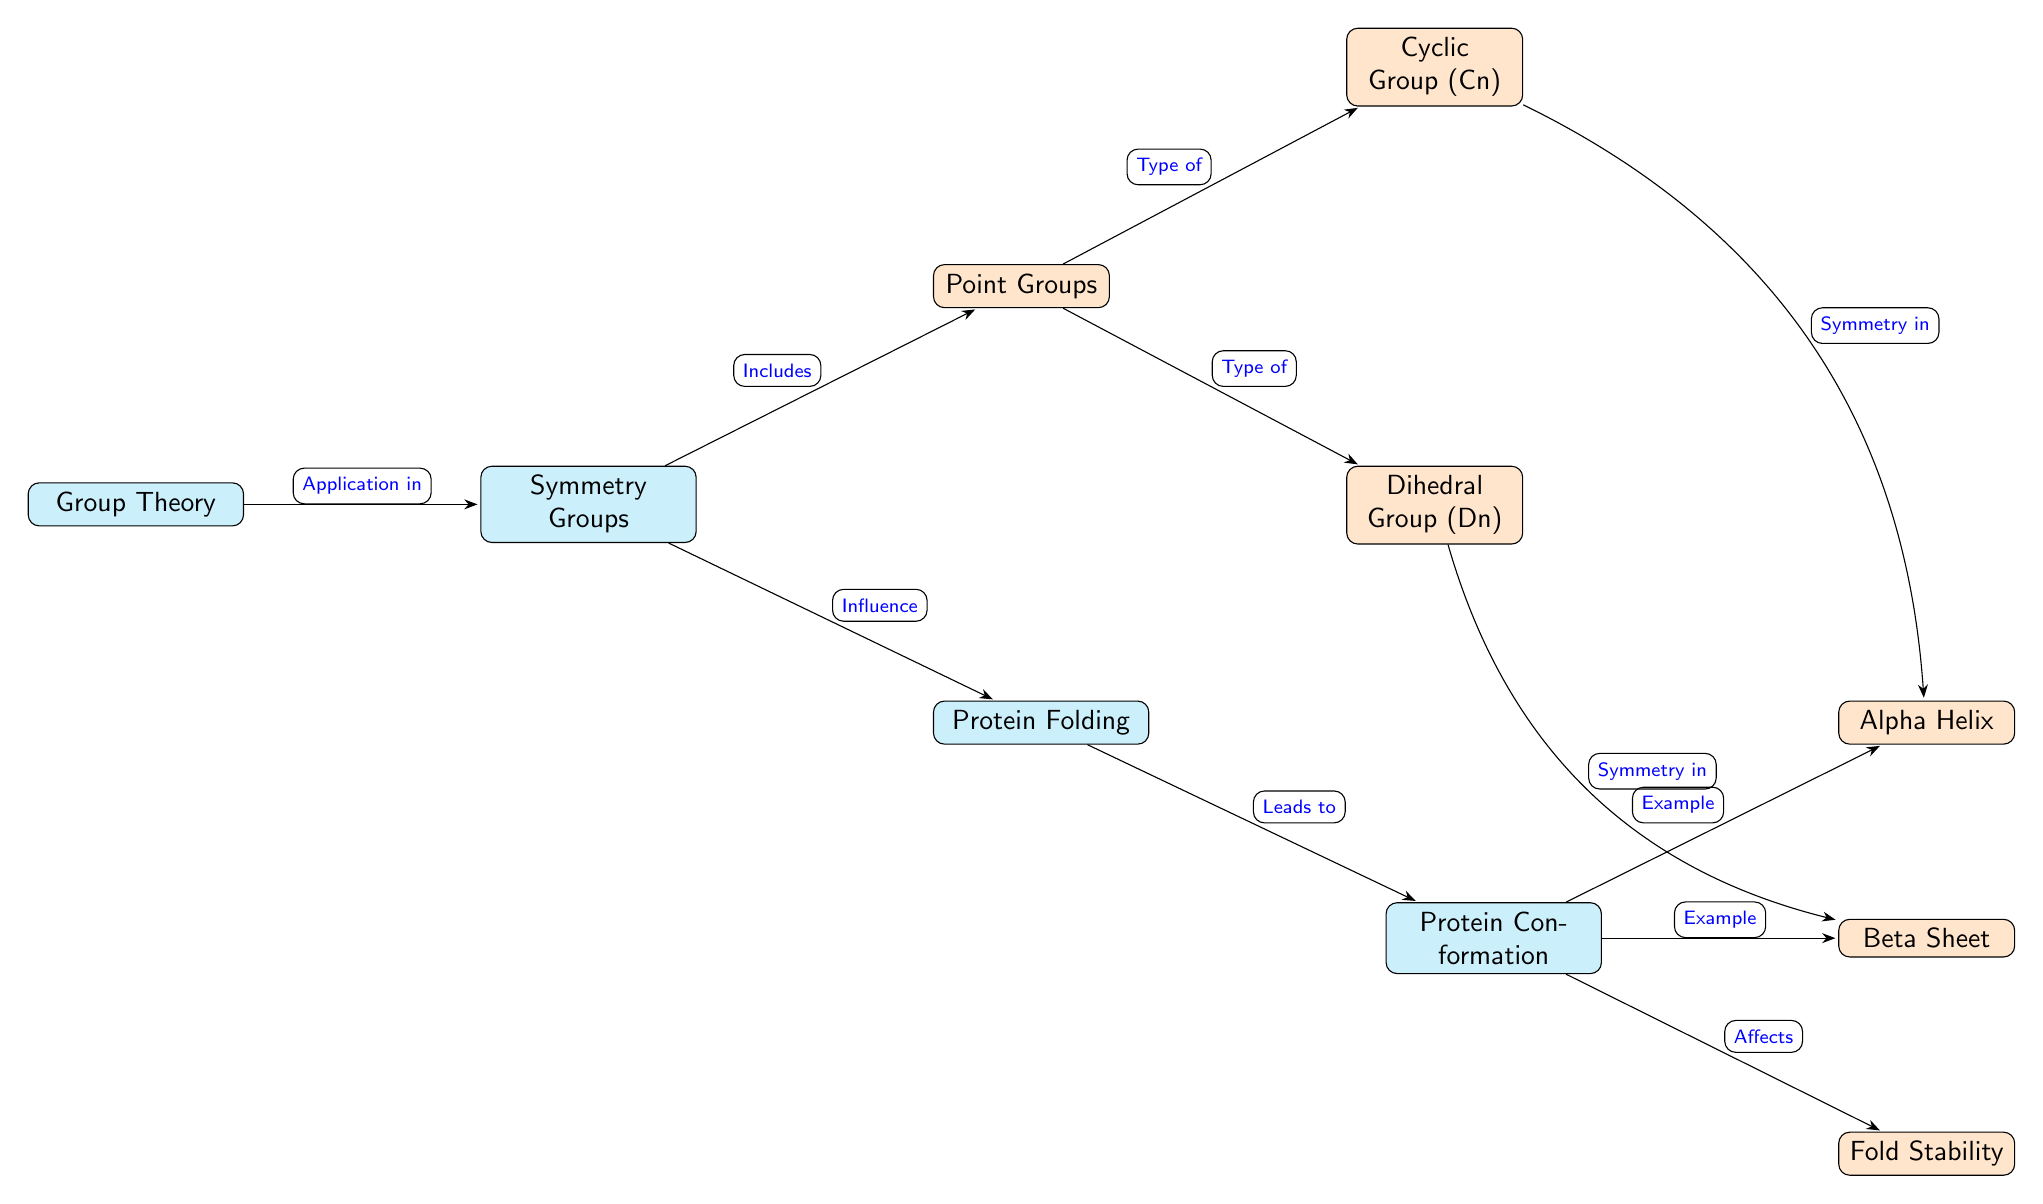What is the main topic represented in the diagram? The top node is labeled "Group Theory," indicating it is the primary topic of the diagram.
Answer: Group Theory Which group is specifically mentioned as a type of symmetry group? The diagram lists "Point Groups" which is connected to "Symmetry Groups," indicating it as a specific type.
Answer: Point Groups How many types of groups are directly shown under the "Point Groups"? There are two groups labeled: "Cyclic Group (Cn)" and "Dihedral Group (Dn)," indicating a total of two types.
Answer: 2 What is the relationship between "Symmetry Groups" and "Protein Folding"? The diagram states that "Symmetry Groups" influence "Protein Folding," showing a directional edge indicating this relationship.
Answer: Influence Which protein conformations are examples listed in the diagram? The diagram indicates "Alpha Helix" and "Beta Sheet" as examples connected to "Protein Conformation."
Answer: Alpha Helix, Beta Sheet What effect does "Protein Conformation" have according to the diagram? The edge from "Protein Conformation" to "Fold Stability" is labeled "Affects," indicating a direct influence.
Answer: Affects What does the diagram imply about the relationship between "Cyclic Group (Cn)" and "Alpha Helix"? The diagram states that there is "Symmetry in" between them, suggesting that the cyclic group contributes to or is related to the symmetry of an alpha helix.
Answer: Symmetry in How does "Dihedral Group (Dn)" relate to "Beta Sheet"? Similar to other relationships noted, the diagram indicates that there is "Symmetry in" between "Dihedral Group (Dn)" and "Beta Sheet."
Answer: Symmetry in 